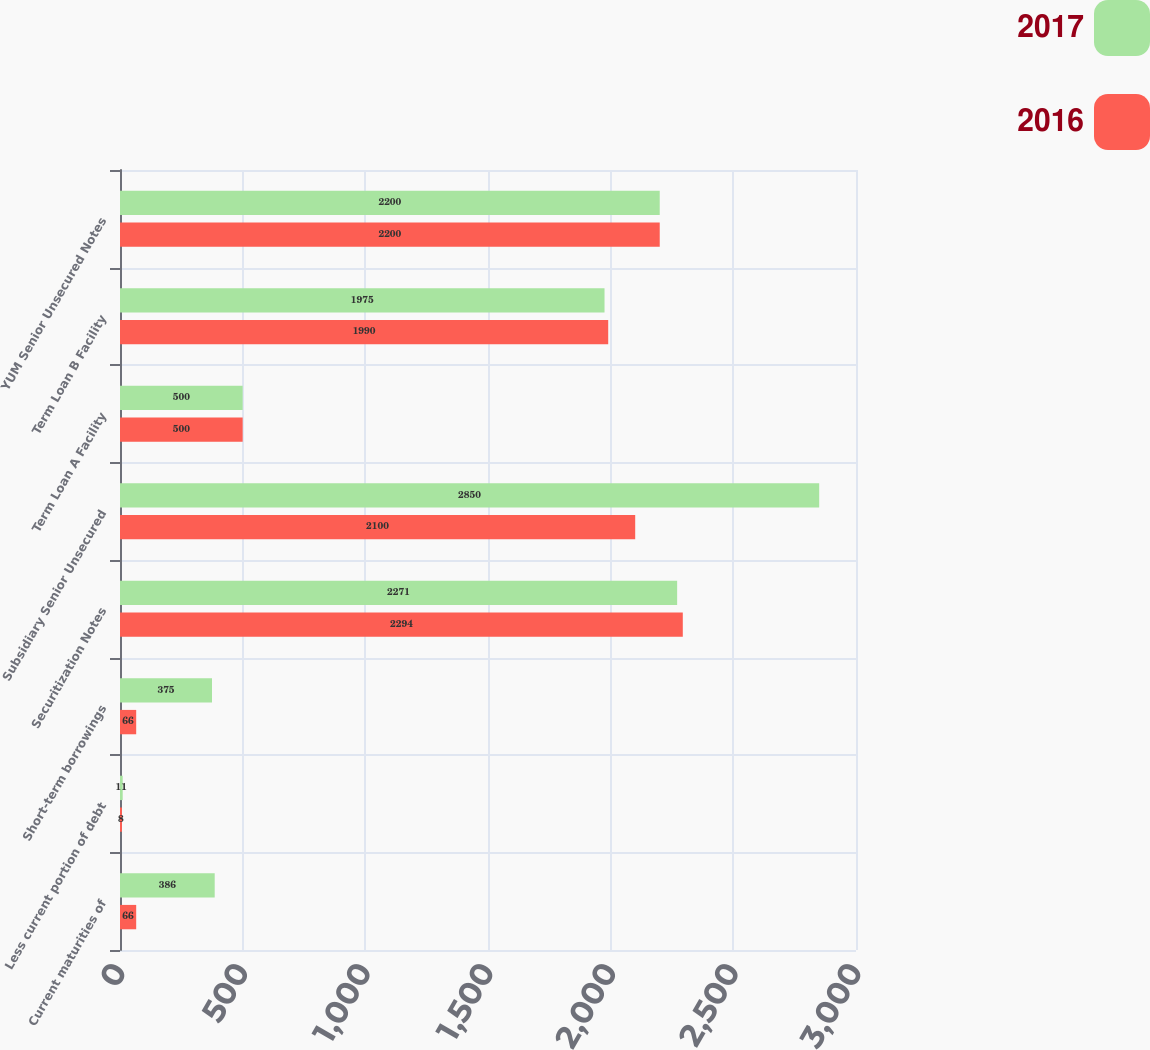Convert chart. <chart><loc_0><loc_0><loc_500><loc_500><stacked_bar_chart><ecel><fcel>Current maturities of<fcel>Less current portion of debt<fcel>Short-term borrowings<fcel>Securitization Notes<fcel>Subsidiary Senior Unsecured<fcel>Term Loan A Facility<fcel>Term Loan B Facility<fcel>YUM Senior Unsecured Notes<nl><fcel>2017<fcel>386<fcel>11<fcel>375<fcel>2271<fcel>2850<fcel>500<fcel>1975<fcel>2200<nl><fcel>2016<fcel>66<fcel>8<fcel>66<fcel>2294<fcel>2100<fcel>500<fcel>1990<fcel>2200<nl></chart> 